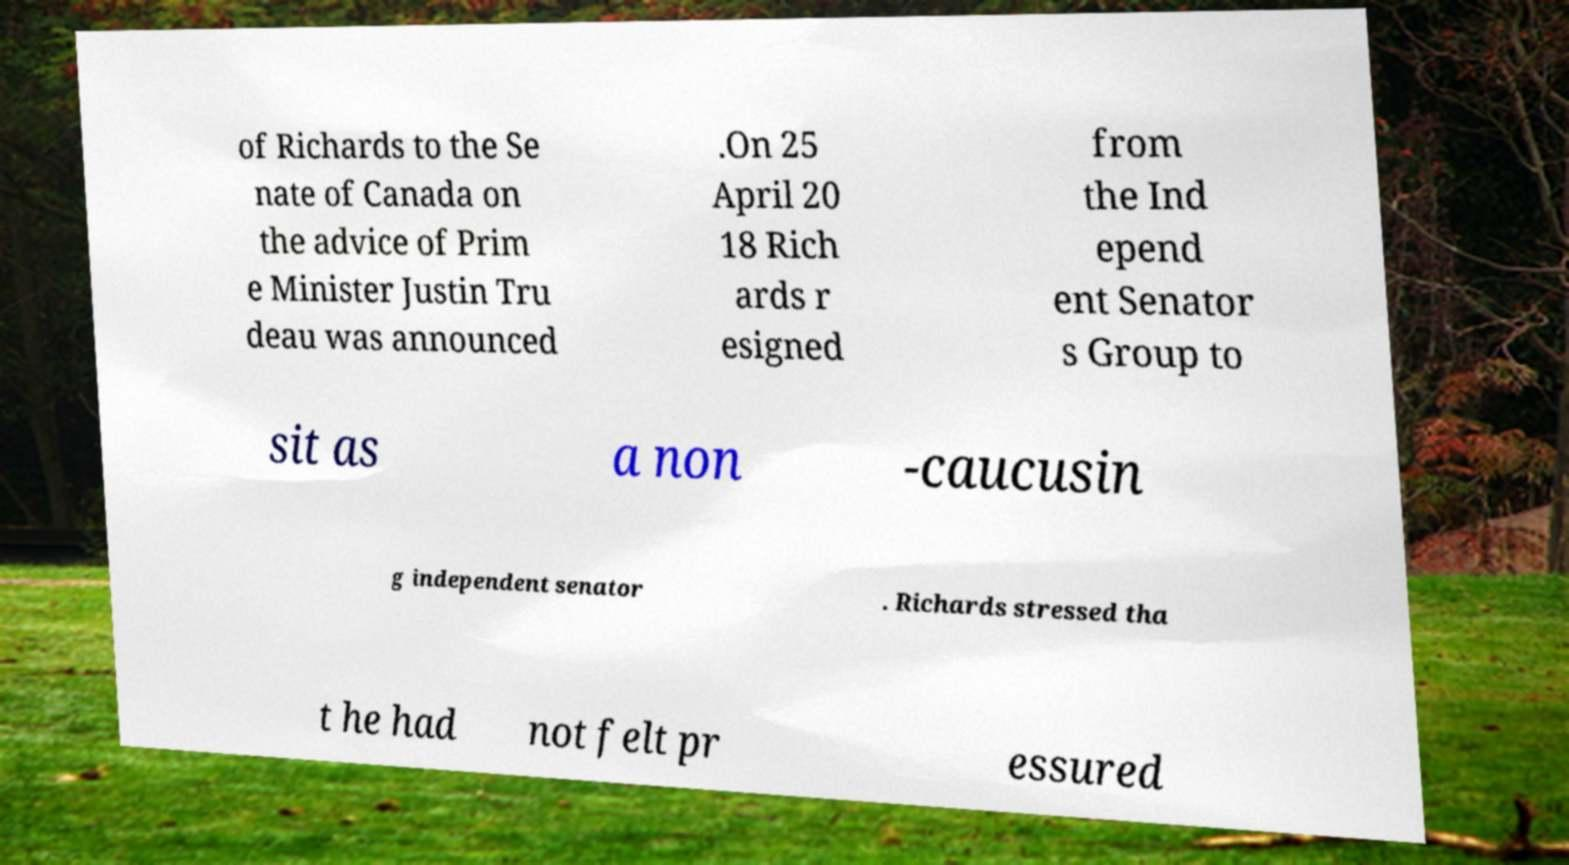For documentation purposes, I need the text within this image transcribed. Could you provide that? of Richards to the Se nate of Canada on the advice of Prim e Minister Justin Tru deau was announced .On 25 April 20 18 Rich ards r esigned from the Ind epend ent Senator s Group to sit as a non -caucusin g independent senator . Richards stressed tha t he had not felt pr essured 